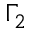<formula> <loc_0><loc_0><loc_500><loc_500>\Gamma _ { 2 }</formula> 